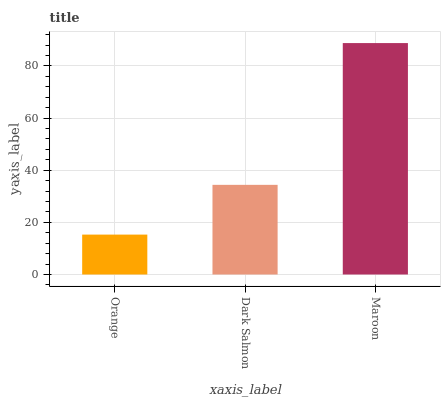Is Orange the minimum?
Answer yes or no. Yes. Is Maroon the maximum?
Answer yes or no. Yes. Is Dark Salmon the minimum?
Answer yes or no. No. Is Dark Salmon the maximum?
Answer yes or no. No. Is Dark Salmon greater than Orange?
Answer yes or no. Yes. Is Orange less than Dark Salmon?
Answer yes or no. Yes. Is Orange greater than Dark Salmon?
Answer yes or no. No. Is Dark Salmon less than Orange?
Answer yes or no. No. Is Dark Salmon the high median?
Answer yes or no. Yes. Is Dark Salmon the low median?
Answer yes or no. Yes. Is Orange the high median?
Answer yes or no. No. Is Orange the low median?
Answer yes or no. No. 